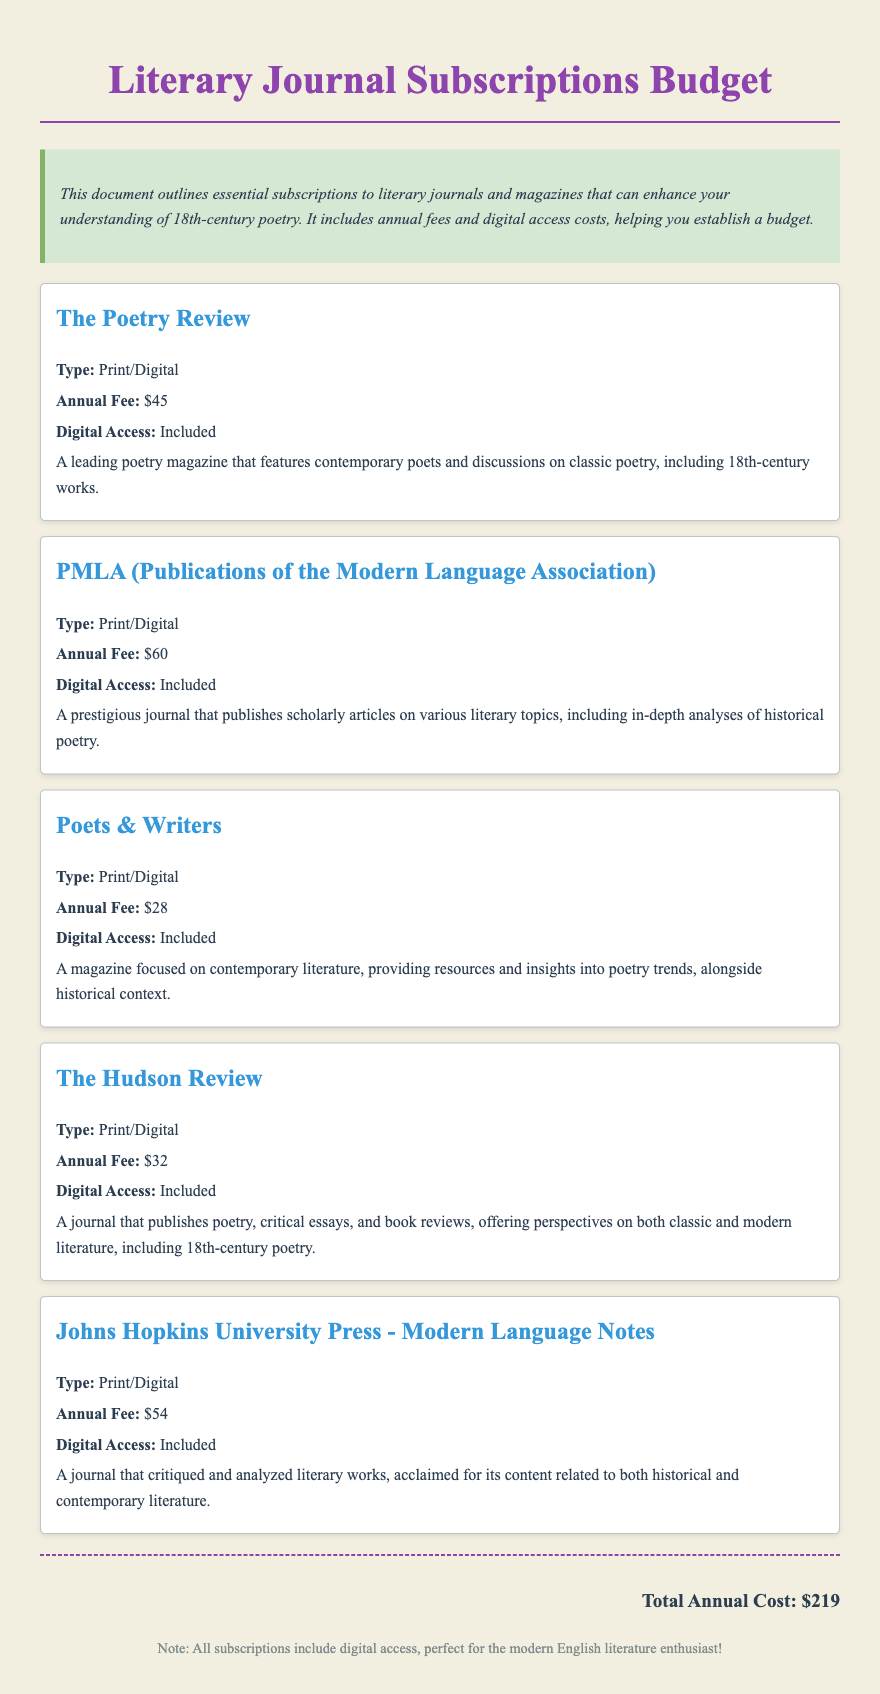What is the annual fee for The Poetry Review? The annual fee listed for The Poetry Review is $45.
Answer: $45 What type of access is included with all subscriptions? The document states that all subscriptions include digital access.
Answer: Digital access How many literary journals are listed in the budget? There are five literary journals mentioned in the document.
Answer: Five What is the total annual cost of all subscriptions? The total annual cost is calculated by adding each annual fee together, which is $219.
Answer: $219 Which journal focuses on contemporary literature? Poets & Writers is highlighted as focusing on contemporary literature.
Answer: Poets & Writers What is the annual fee for PMLA? The annual fee for PMLA is $60.
Answer: $60 Which journal publishes critical essays and book reviews? The Hudson Review publishes critical essays and book reviews.
Answer: The Hudson Review What is the annual fee for Johns Hopkins University Press - Modern Language Notes? The annual fee for this journal is $54.
Answer: $54 What type of subscription does The Hudson Review offer? The subscription type for The Hudson Review is Print/Digital.
Answer: Print/Digital 